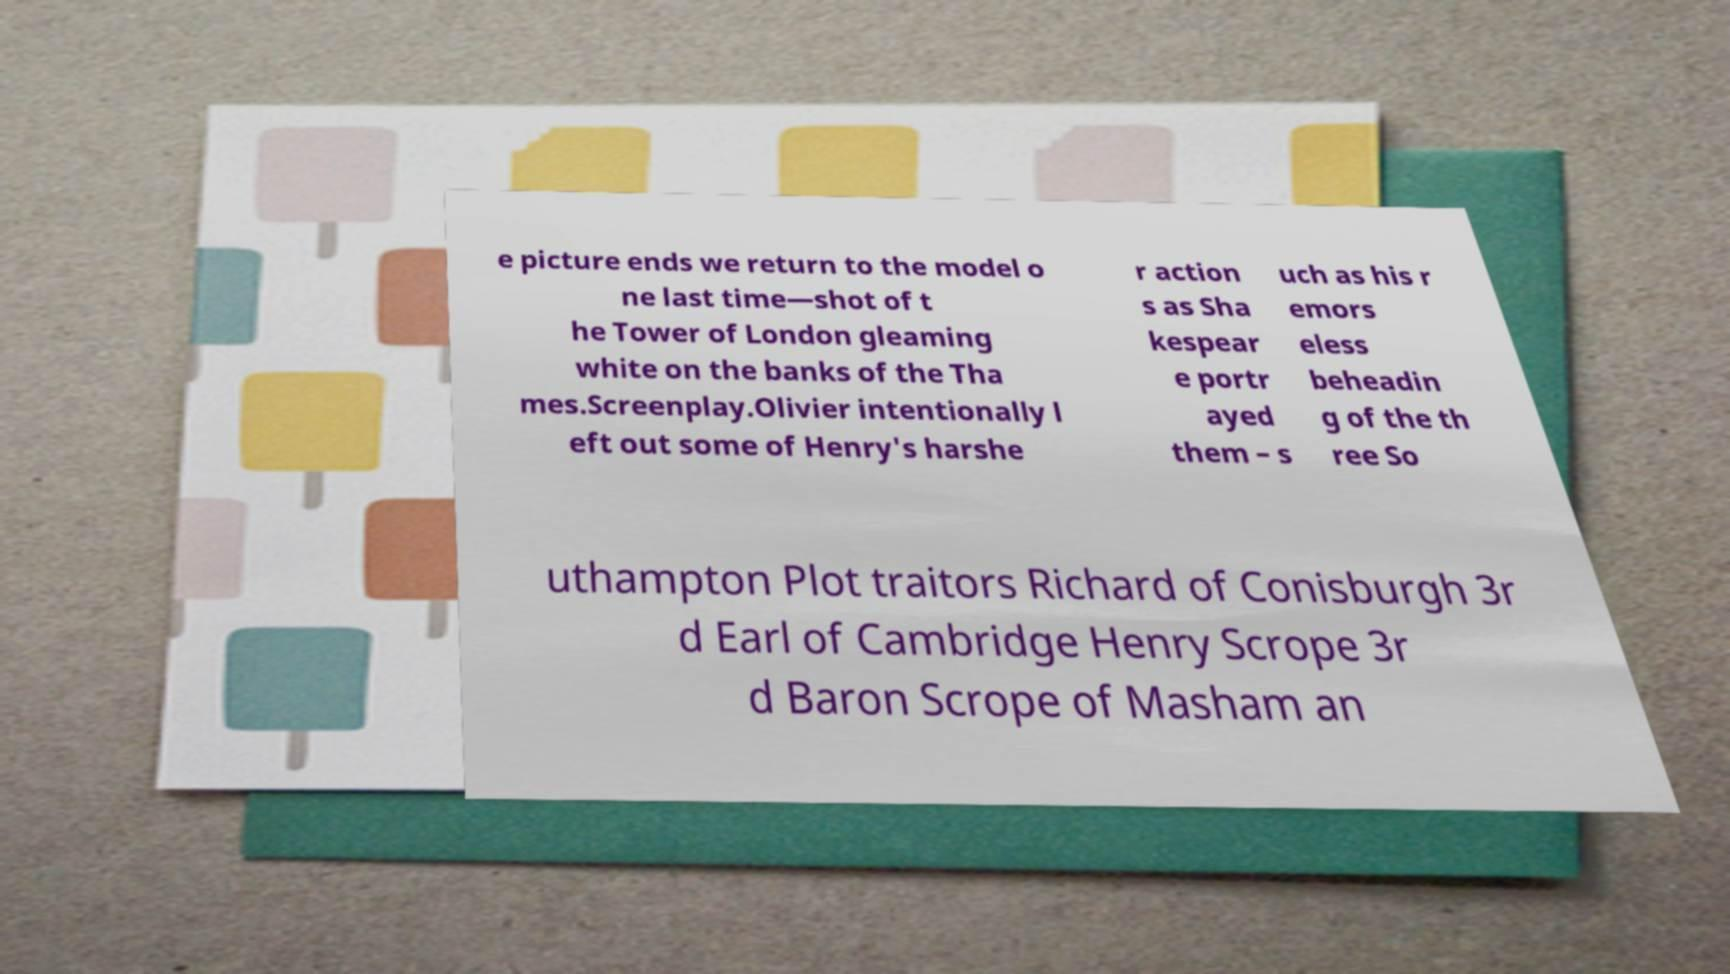Can you read and provide the text displayed in the image?This photo seems to have some interesting text. Can you extract and type it out for me? e picture ends we return to the model o ne last time—shot of t he Tower of London gleaming white on the banks of the Tha mes.Screenplay.Olivier intentionally l eft out some of Henry's harshe r action s as Sha kespear e portr ayed them – s uch as his r emors eless beheadin g of the th ree So uthampton Plot traitors Richard of Conisburgh 3r d Earl of Cambridge Henry Scrope 3r d Baron Scrope of Masham an 